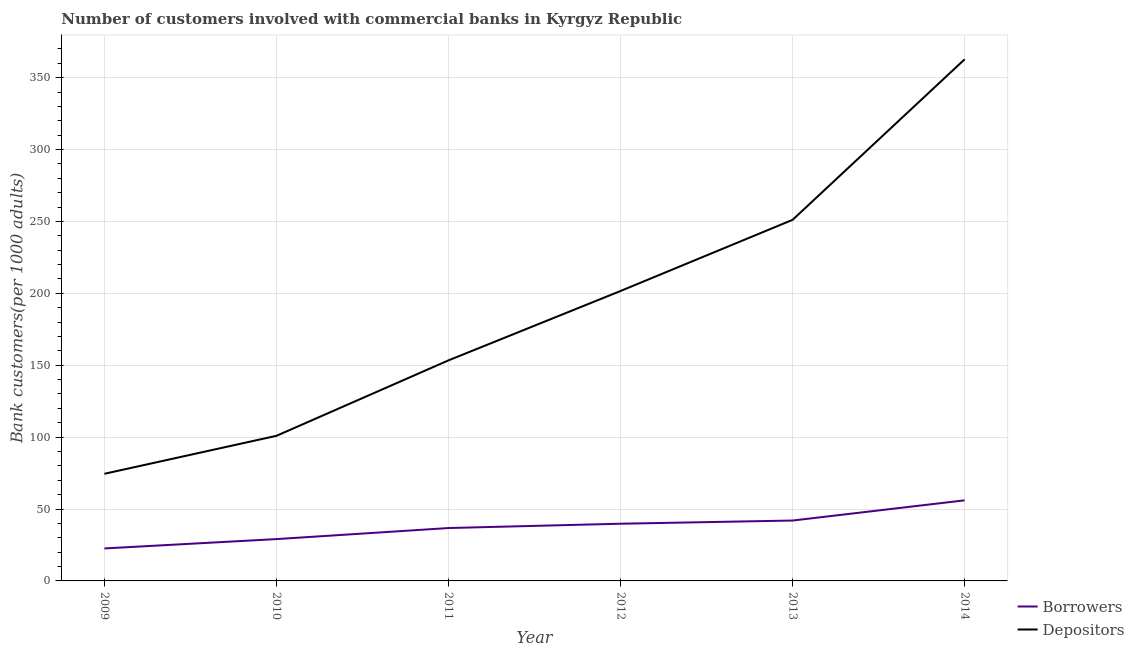How many different coloured lines are there?
Your answer should be very brief. 2. Does the line corresponding to number of depositors intersect with the line corresponding to number of borrowers?
Your answer should be very brief. No. What is the number of depositors in 2013?
Offer a terse response. 251.12. Across all years, what is the maximum number of depositors?
Give a very brief answer. 362.74. Across all years, what is the minimum number of depositors?
Your response must be concise. 74.51. What is the total number of borrowers in the graph?
Make the answer very short. 226.28. What is the difference between the number of borrowers in 2010 and that in 2011?
Your response must be concise. -7.68. What is the difference between the number of depositors in 2013 and the number of borrowers in 2010?
Provide a short and direct response. 222.02. What is the average number of borrowers per year?
Keep it short and to the point. 37.71. In the year 2009, what is the difference between the number of depositors and number of borrowers?
Give a very brief answer. 51.92. In how many years, is the number of borrowers greater than 340?
Ensure brevity in your answer.  0. What is the ratio of the number of depositors in 2009 to that in 2011?
Your answer should be compact. 0.49. Is the number of borrowers in 2010 less than that in 2011?
Ensure brevity in your answer.  Yes. What is the difference between the highest and the second highest number of depositors?
Offer a terse response. 111.63. What is the difference between the highest and the lowest number of borrowers?
Make the answer very short. 33.45. In how many years, is the number of borrowers greater than the average number of borrowers taken over all years?
Your answer should be compact. 3. Does the graph contain any zero values?
Make the answer very short. No. Where does the legend appear in the graph?
Provide a succinct answer. Bottom right. What is the title of the graph?
Make the answer very short. Number of customers involved with commercial banks in Kyrgyz Republic. Does "Under-5(male)" appear as one of the legend labels in the graph?
Your answer should be compact. No. What is the label or title of the X-axis?
Your response must be concise. Year. What is the label or title of the Y-axis?
Ensure brevity in your answer.  Bank customers(per 1000 adults). What is the Bank customers(per 1000 adults) in Borrowers in 2009?
Ensure brevity in your answer.  22.59. What is the Bank customers(per 1000 adults) in Depositors in 2009?
Make the answer very short. 74.51. What is the Bank customers(per 1000 adults) of Borrowers in 2010?
Offer a very short reply. 29.09. What is the Bank customers(per 1000 adults) of Depositors in 2010?
Provide a succinct answer. 100.91. What is the Bank customers(per 1000 adults) of Borrowers in 2011?
Provide a short and direct response. 36.78. What is the Bank customers(per 1000 adults) of Depositors in 2011?
Your answer should be compact. 153.38. What is the Bank customers(per 1000 adults) in Borrowers in 2012?
Your answer should be very brief. 39.78. What is the Bank customers(per 1000 adults) in Depositors in 2012?
Your answer should be very brief. 201.64. What is the Bank customers(per 1000 adults) in Borrowers in 2013?
Provide a succinct answer. 42. What is the Bank customers(per 1000 adults) in Depositors in 2013?
Ensure brevity in your answer.  251.12. What is the Bank customers(per 1000 adults) of Borrowers in 2014?
Make the answer very short. 56.04. What is the Bank customers(per 1000 adults) in Depositors in 2014?
Offer a very short reply. 362.74. Across all years, what is the maximum Bank customers(per 1000 adults) of Borrowers?
Provide a succinct answer. 56.04. Across all years, what is the maximum Bank customers(per 1000 adults) of Depositors?
Provide a succinct answer. 362.74. Across all years, what is the minimum Bank customers(per 1000 adults) of Borrowers?
Provide a short and direct response. 22.59. Across all years, what is the minimum Bank customers(per 1000 adults) in Depositors?
Your response must be concise. 74.51. What is the total Bank customers(per 1000 adults) of Borrowers in the graph?
Keep it short and to the point. 226.28. What is the total Bank customers(per 1000 adults) of Depositors in the graph?
Keep it short and to the point. 1144.3. What is the difference between the Bank customers(per 1000 adults) of Borrowers in 2009 and that in 2010?
Offer a very short reply. -6.5. What is the difference between the Bank customers(per 1000 adults) of Depositors in 2009 and that in 2010?
Your answer should be very brief. -26.4. What is the difference between the Bank customers(per 1000 adults) of Borrowers in 2009 and that in 2011?
Give a very brief answer. -14.19. What is the difference between the Bank customers(per 1000 adults) of Depositors in 2009 and that in 2011?
Offer a terse response. -78.87. What is the difference between the Bank customers(per 1000 adults) in Borrowers in 2009 and that in 2012?
Give a very brief answer. -17.19. What is the difference between the Bank customers(per 1000 adults) in Depositors in 2009 and that in 2012?
Your response must be concise. -127.13. What is the difference between the Bank customers(per 1000 adults) in Borrowers in 2009 and that in 2013?
Your response must be concise. -19.41. What is the difference between the Bank customers(per 1000 adults) in Depositors in 2009 and that in 2013?
Your answer should be compact. -176.61. What is the difference between the Bank customers(per 1000 adults) in Borrowers in 2009 and that in 2014?
Make the answer very short. -33.45. What is the difference between the Bank customers(per 1000 adults) of Depositors in 2009 and that in 2014?
Your answer should be compact. -288.23. What is the difference between the Bank customers(per 1000 adults) of Borrowers in 2010 and that in 2011?
Keep it short and to the point. -7.68. What is the difference between the Bank customers(per 1000 adults) of Depositors in 2010 and that in 2011?
Provide a succinct answer. -52.48. What is the difference between the Bank customers(per 1000 adults) in Borrowers in 2010 and that in 2012?
Provide a short and direct response. -10.69. What is the difference between the Bank customers(per 1000 adults) of Depositors in 2010 and that in 2012?
Ensure brevity in your answer.  -100.73. What is the difference between the Bank customers(per 1000 adults) of Borrowers in 2010 and that in 2013?
Your answer should be compact. -12.9. What is the difference between the Bank customers(per 1000 adults) of Depositors in 2010 and that in 2013?
Give a very brief answer. -150.21. What is the difference between the Bank customers(per 1000 adults) of Borrowers in 2010 and that in 2014?
Give a very brief answer. -26.95. What is the difference between the Bank customers(per 1000 adults) in Depositors in 2010 and that in 2014?
Give a very brief answer. -261.84. What is the difference between the Bank customers(per 1000 adults) in Borrowers in 2011 and that in 2012?
Offer a terse response. -3. What is the difference between the Bank customers(per 1000 adults) of Depositors in 2011 and that in 2012?
Your answer should be compact. -48.25. What is the difference between the Bank customers(per 1000 adults) in Borrowers in 2011 and that in 2013?
Offer a terse response. -5.22. What is the difference between the Bank customers(per 1000 adults) in Depositors in 2011 and that in 2013?
Your answer should be compact. -97.73. What is the difference between the Bank customers(per 1000 adults) in Borrowers in 2011 and that in 2014?
Your answer should be compact. -19.26. What is the difference between the Bank customers(per 1000 adults) in Depositors in 2011 and that in 2014?
Make the answer very short. -209.36. What is the difference between the Bank customers(per 1000 adults) of Borrowers in 2012 and that in 2013?
Your answer should be compact. -2.22. What is the difference between the Bank customers(per 1000 adults) of Depositors in 2012 and that in 2013?
Provide a succinct answer. -49.48. What is the difference between the Bank customers(per 1000 adults) of Borrowers in 2012 and that in 2014?
Give a very brief answer. -16.26. What is the difference between the Bank customers(per 1000 adults) in Depositors in 2012 and that in 2014?
Give a very brief answer. -161.11. What is the difference between the Bank customers(per 1000 adults) in Borrowers in 2013 and that in 2014?
Keep it short and to the point. -14.04. What is the difference between the Bank customers(per 1000 adults) of Depositors in 2013 and that in 2014?
Keep it short and to the point. -111.63. What is the difference between the Bank customers(per 1000 adults) in Borrowers in 2009 and the Bank customers(per 1000 adults) in Depositors in 2010?
Give a very brief answer. -78.32. What is the difference between the Bank customers(per 1000 adults) in Borrowers in 2009 and the Bank customers(per 1000 adults) in Depositors in 2011?
Keep it short and to the point. -130.79. What is the difference between the Bank customers(per 1000 adults) of Borrowers in 2009 and the Bank customers(per 1000 adults) of Depositors in 2012?
Make the answer very short. -179.05. What is the difference between the Bank customers(per 1000 adults) in Borrowers in 2009 and the Bank customers(per 1000 adults) in Depositors in 2013?
Ensure brevity in your answer.  -228.53. What is the difference between the Bank customers(per 1000 adults) of Borrowers in 2009 and the Bank customers(per 1000 adults) of Depositors in 2014?
Provide a short and direct response. -340.15. What is the difference between the Bank customers(per 1000 adults) of Borrowers in 2010 and the Bank customers(per 1000 adults) of Depositors in 2011?
Offer a very short reply. -124.29. What is the difference between the Bank customers(per 1000 adults) of Borrowers in 2010 and the Bank customers(per 1000 adults) of Depositors in 2012?
Offer a terse response. -172.54. What is the difference between the Bank customers(per 1000 adults) of Borrowers in 2010 and the Bank customers(per 1000 adults) of Depositors in 2013?
Make the answer very short. -222.02. What is the difference between the Bank customers(per 1000 adults) of Borrowers in 2010 and the Bank customers(per 1000 adults) of Depositors in 2014?
Offer a very short reply. -333.65. What is the difference between the Bank customers(per 1000 adults) of Borrowers in 2011 and the Bank customers(per 1000 adults) of Depositors in 2012?
Offer a very short reply. -164.86. What is the difference between the Bank customers(per 1000 adults) of Borrowers in 2011 and the Bank customers(per 1000 adults) of Depositors in 2013?
Your response must be concise. -214.34. What is the difference between the Bank customers(per 1000 adults) of Borrowers in 2011 and the Bank customers(per 1000 adults) of Depositors in 2014?
Your answer should be very brief. -325.97. What is the difference between the Bank customers(per 1000 adults) of Borrowers in 2012 and the Bank customers(per 1000 adults) of Depositors in 2013?
Make the answer very short. -211.34. What is the difference between the Bank customers(per 1000 adults) in Borrowers in 2012 and the Bank customers(per 1000 adults) in Depositors in 2014?
Ensure brevity in your answer.  -322.96. What is the difference between the Bank customers(per 1000 adults) in Borrowers in 2013 and the Bank customers(per 1000 adults) in Depositors in 2014?
Offer a terse response. -320.75. What is the average Bank customers(per 1000 adults) of Borrowers per year?
Provide a succinct answer. 37.71. What is the average Bank customers(per 1000 adults) in Depositors per year?
Provide a short and direct response. 190.72. In the year 2009, what is the difference between the Bank customers(per 1000 adults) of Borrowers and Bank customers(per 1000 adults) of Depositors?
Provide a succinct answer. -51.92. In the year 2010, what is the difference between the Bank customers(per 1000 adults) in Borrowers and Bank customers(per 1000 adults) in Depositors?
Provide a succinct answer. -71.81. In the year 2011, what is the difference between the Bank customers(per 1000 adults) in Borrowers and Bank customers(per 1000 adults) in Depositors?
Your answer should be compact. -116.61. In the year 2012, what is the difference between the Bank customers(per 1000 adults) of Borrowers and Bank customers(per 1000 adults) of Depositors?
Give a very brief answer. -161.86. In the year 2013, what is the difference between the Bank customers(per 1000 adults) of Borrowers and Bank customers(per 1000 adults) of Depositors?
Ensure brevity in your answer.  -209.12. In the year 2014, what is the difference between the Bank customers(per 1000 adults) in Borrowers and Bank customers(per 1000 adults) in Depositors?
Ensure brevity in your answer.  -306.7. What is the ratio of the Bank customers(per 1000 adults) of Borrowers in 2009 to that in 2010?
Your answer should be compact. 0.78. What is the ratio of the Bank customers(per 1000 adults) of Depositors in 2009 to that in 2010?
Your answer should be compact. 0.74. What is the ratio of the Bank customers(per 1000 adults) in Borrowers in 2009 to that in 2011?
Keep it short and to the point. 0.61. What is the ratio of the Bank customers(per 1000 adults) in Depositors in 2009 to that in 2011?
Your response must be concise. 0.49. What is the ratio of the Bank customers(per 1000 adults) of Borrowers in 2009 to that in 2012?
Offer a very short reply. 0.57. What is the ratio of the Bank customers(per 1000 adults) in Depositors in 2009 to that in 2012?
Give a very brief answer. 0.37. What is the ratio of the Bank customers(per 1000 adults) of Borrowers in 2009 to that in 2013?
Offer a terse response. 0.54. What is the ratio of the Bank customers(per 1000 adults) of Depositors in 2009 to that in 2013?
Keep it short and to the point. 0.3. What is the ratio of the Bank customers(per 1000 adults) in Borrowers in 2009 to that in 2014?
Your answer should be compact. 0.4. What is the ratio of the Bank customers(per 1000 adults) in Depositors in 2009 to that in 2014?
Provide a succinct answer. 0.21. What is the ratio of the Bank customers(per 1000 adults) of Borrowers in 2010 to that in 2011?
Provide a short and direct response. 0.79. What is the ratio of the Bank customers(per 1000 adults) in Depositors in 2010 to that in 2011?
Provide a succinct answer. 0.66. What is the ratio of the Bank customers(per 1000 adults) of Borrowers in 2010 to that in 2012?
Give a very brief answer. 0.73. What is the ratio of the Bank customers(per 1000 adults) of Depositors in 2010 to that in 2012?
Offer a very short reply. 0.5. What is the ratio of the Bank customers(per 1000 adults) in Borrowers in 2010 to that in 2013?
Provide a succinct answer. 0.69. What is the ratio of the Bank customers(per 1000 adults) in Depositors in 2010 to that in 2013?
Ensure brevity in your answer.  0.4. What is the ratio of the Bank customers(per 1000 adults) in Borrowers in 2010 to that in 2014?
Provide a short and direct response. 0.52. What is the ratio of the Bank customers(per 1000 adults) of Depositors in 2010 to that in 2014?
Your answer should be compact. 0.28. What is the ratio of the Bank customers(per 1000 adults) in Borrowers in 2011 to that in 2012?
Keep it short and to the point. 0.92. What is the ratio of the Bank customers(per 1000 adults) of Depositors in 2011 to that in 2012?
Provide a short and direct response. 0.76. What is the ratio of the Bank customers(per 1000 adults) in Borrowers in 2011 to that in 2013?
Offer a terse response. 0.88. What is the ratio of the Bank customers(per 1000 adults) of Depositors in 2011 to that in 2013?
Your answer should be compact. 0.61. What is the ratio of the Bank customers(per 1000 adults) in Borrowers in 2011 to that in 2014?
Give a very brief answer. 0.66. What is the ratio of the Bank customers(per 1000 adults) of Depositors in 2011 to that in 2014?
Ensure brevity in your answer.  0.42. What is the ratio of the Bank customers(per 1000 adults) of Borrowers in 2012 to that in 2013?
Your answer should be compact. 0.95. What is the ratio of the Bank customers(per 1000 adults) of Depositors in 2012 to that in 2013?
Your answer should be very brief. 0.8. What is the ratio of the Bank customers(per 1000 adults) of Borrowers in 2012 to that in 2014?
Your response must be concise. 0.71. What is the ratio of the Bank customers(per 1000 adults) of Depositors in 2012 to that in 2014?
Your answer should be very brief. 0.56. What is the ratio of the Bank customers(per 1000 adults) in Borrowers in 2013 to that in 2014?
Keep it short and to the point. 0.75. What is the ratio of the Bank customers(per 1000 adults) in Depositors in 2013 to that in 2014?
Offer a very short reply. 0.69. What is the difference between the highest and the second highest Bank customers(per 1000 adults) in Borrowers?
Your answer should be very brief. 14.04. What is the difference between the highest and the second highest Bank customers(per 1000 adults) of Depositors?
Make the answer very short. 111.63. What is the difference between the highest and the lowest Bank customers(per 1000 adults) of Borrowers?
Your answer should be compact. 33.45. What is the difference between the highest and the lowest Bank customers(per 1000 adults) in Depositors?
Offer a very short reply. 288.23. 